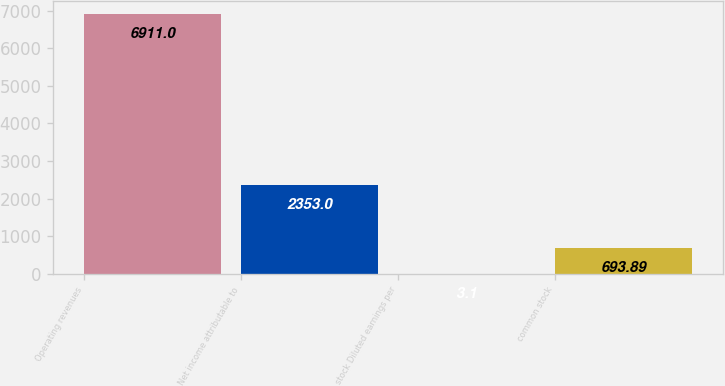Convert chart to OTSL. <chart><loc_0><loc_0><loc_500><loc_500><bar_chart><fcel>Operating revenues<fcel>Net income attributable to<fcel>stock Diluted earnings per<fcel>common stock<nl><fcel>6911<fcel>2353<fcel>3.1<fcel>693.89<nl></chart> 